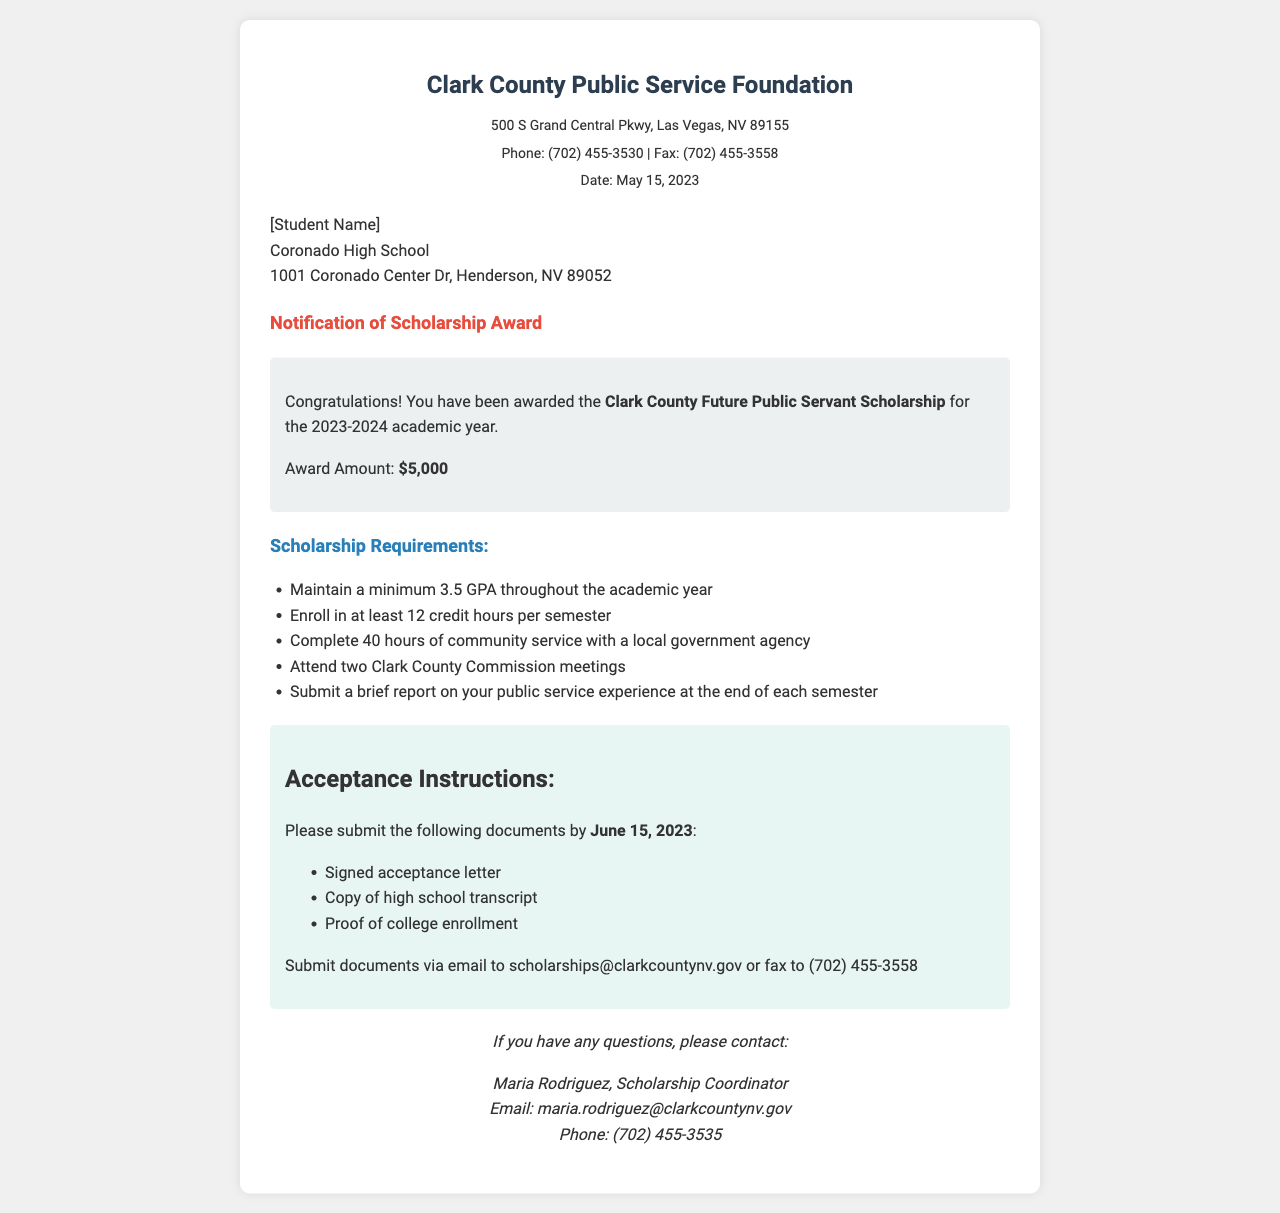What is the name of the scholarship? The name of the scholarship is stated in the award details section of the document.
Answer: Clark County Future Public Servant Scholarship What is the award amount? The award amount is shown in the award details section of the document.
Answer: $5,000 What is the minimum GPA required? The minimum GPA required is listed in the scholarship requirements section of the document.
Answer: 3.5 How many community service hours must be completed? The number of community service hours required is mentioned in the requirements.
Answer: 40 hours By when must acceptance documents be submitted? The deadline for submitting acceptance documents is indicated in the acceptance instructions section.
Answer: June 15, 2023 Who is the contact person for questions? The contact person's name is provided in the contact section of the document.
Answer: Maria Rodriguez What is the email address for submitting documents? The email address for submissions is specified in the acceptance instructions section.
Answer: scholarships@clarkcountynv.gov How many credit hours must be enrolled in each semester? The number of credit hours required for enrollment is mentioned in the scholarship requirements.
Answer: 12 credit hours What type of meetings must be attended? The type of meetings that need to be attended is specified in the scholarship requirements.
Answer: Clark County Commission meetings 